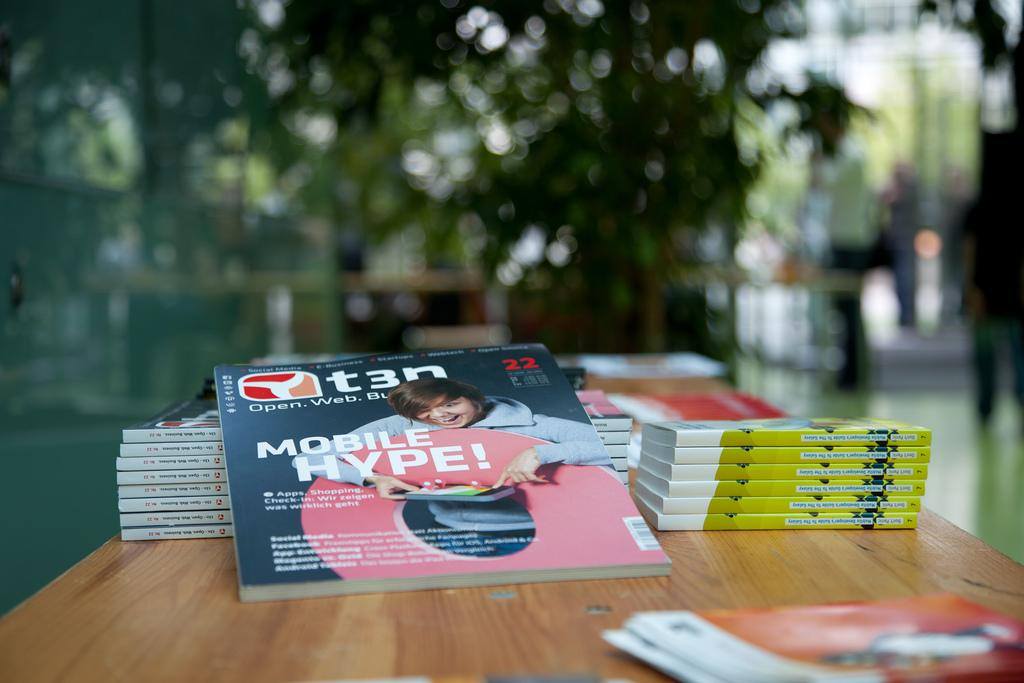<image>
Render a clear and concise summary of the photo. Mobile Hype! book next to some other books on a table. 